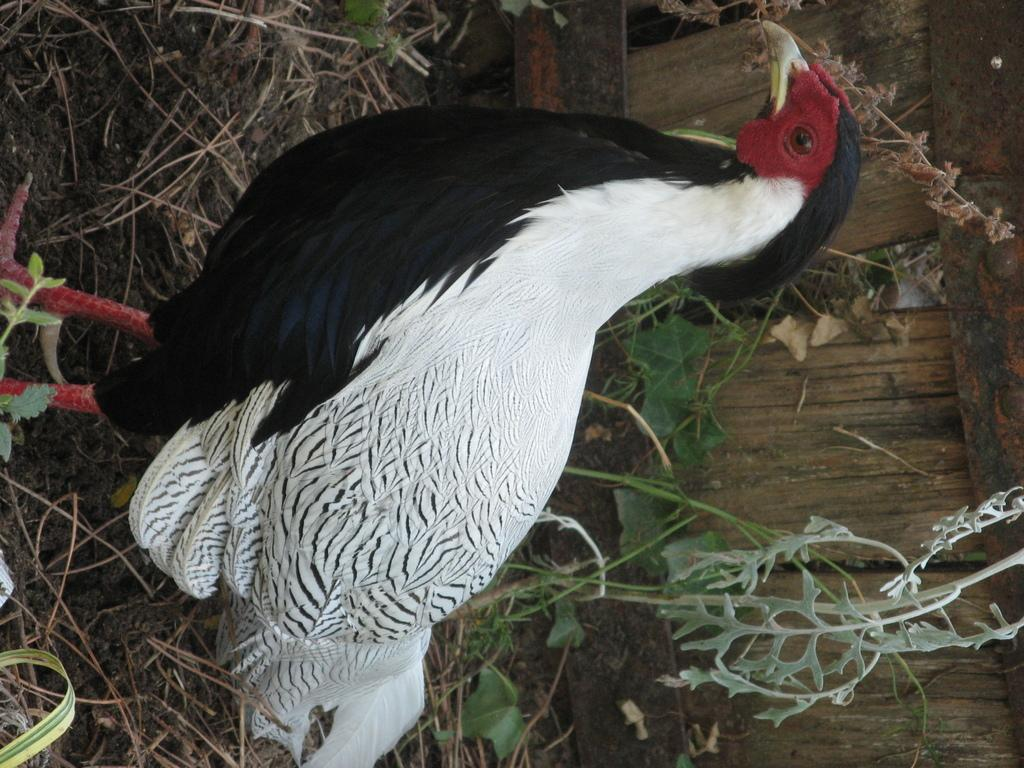What animal can be seen in the image? There is a hen in the image. What can be seen in the background of the image? There are plants and dry grass on the ground in the background. What type of material is the wooden plank made of? The wooden plank is made of wood. What type of roof can be seen on the hen in the image? There is no roof present in the image, as it features a hen and other elements in an outdoor setting. 